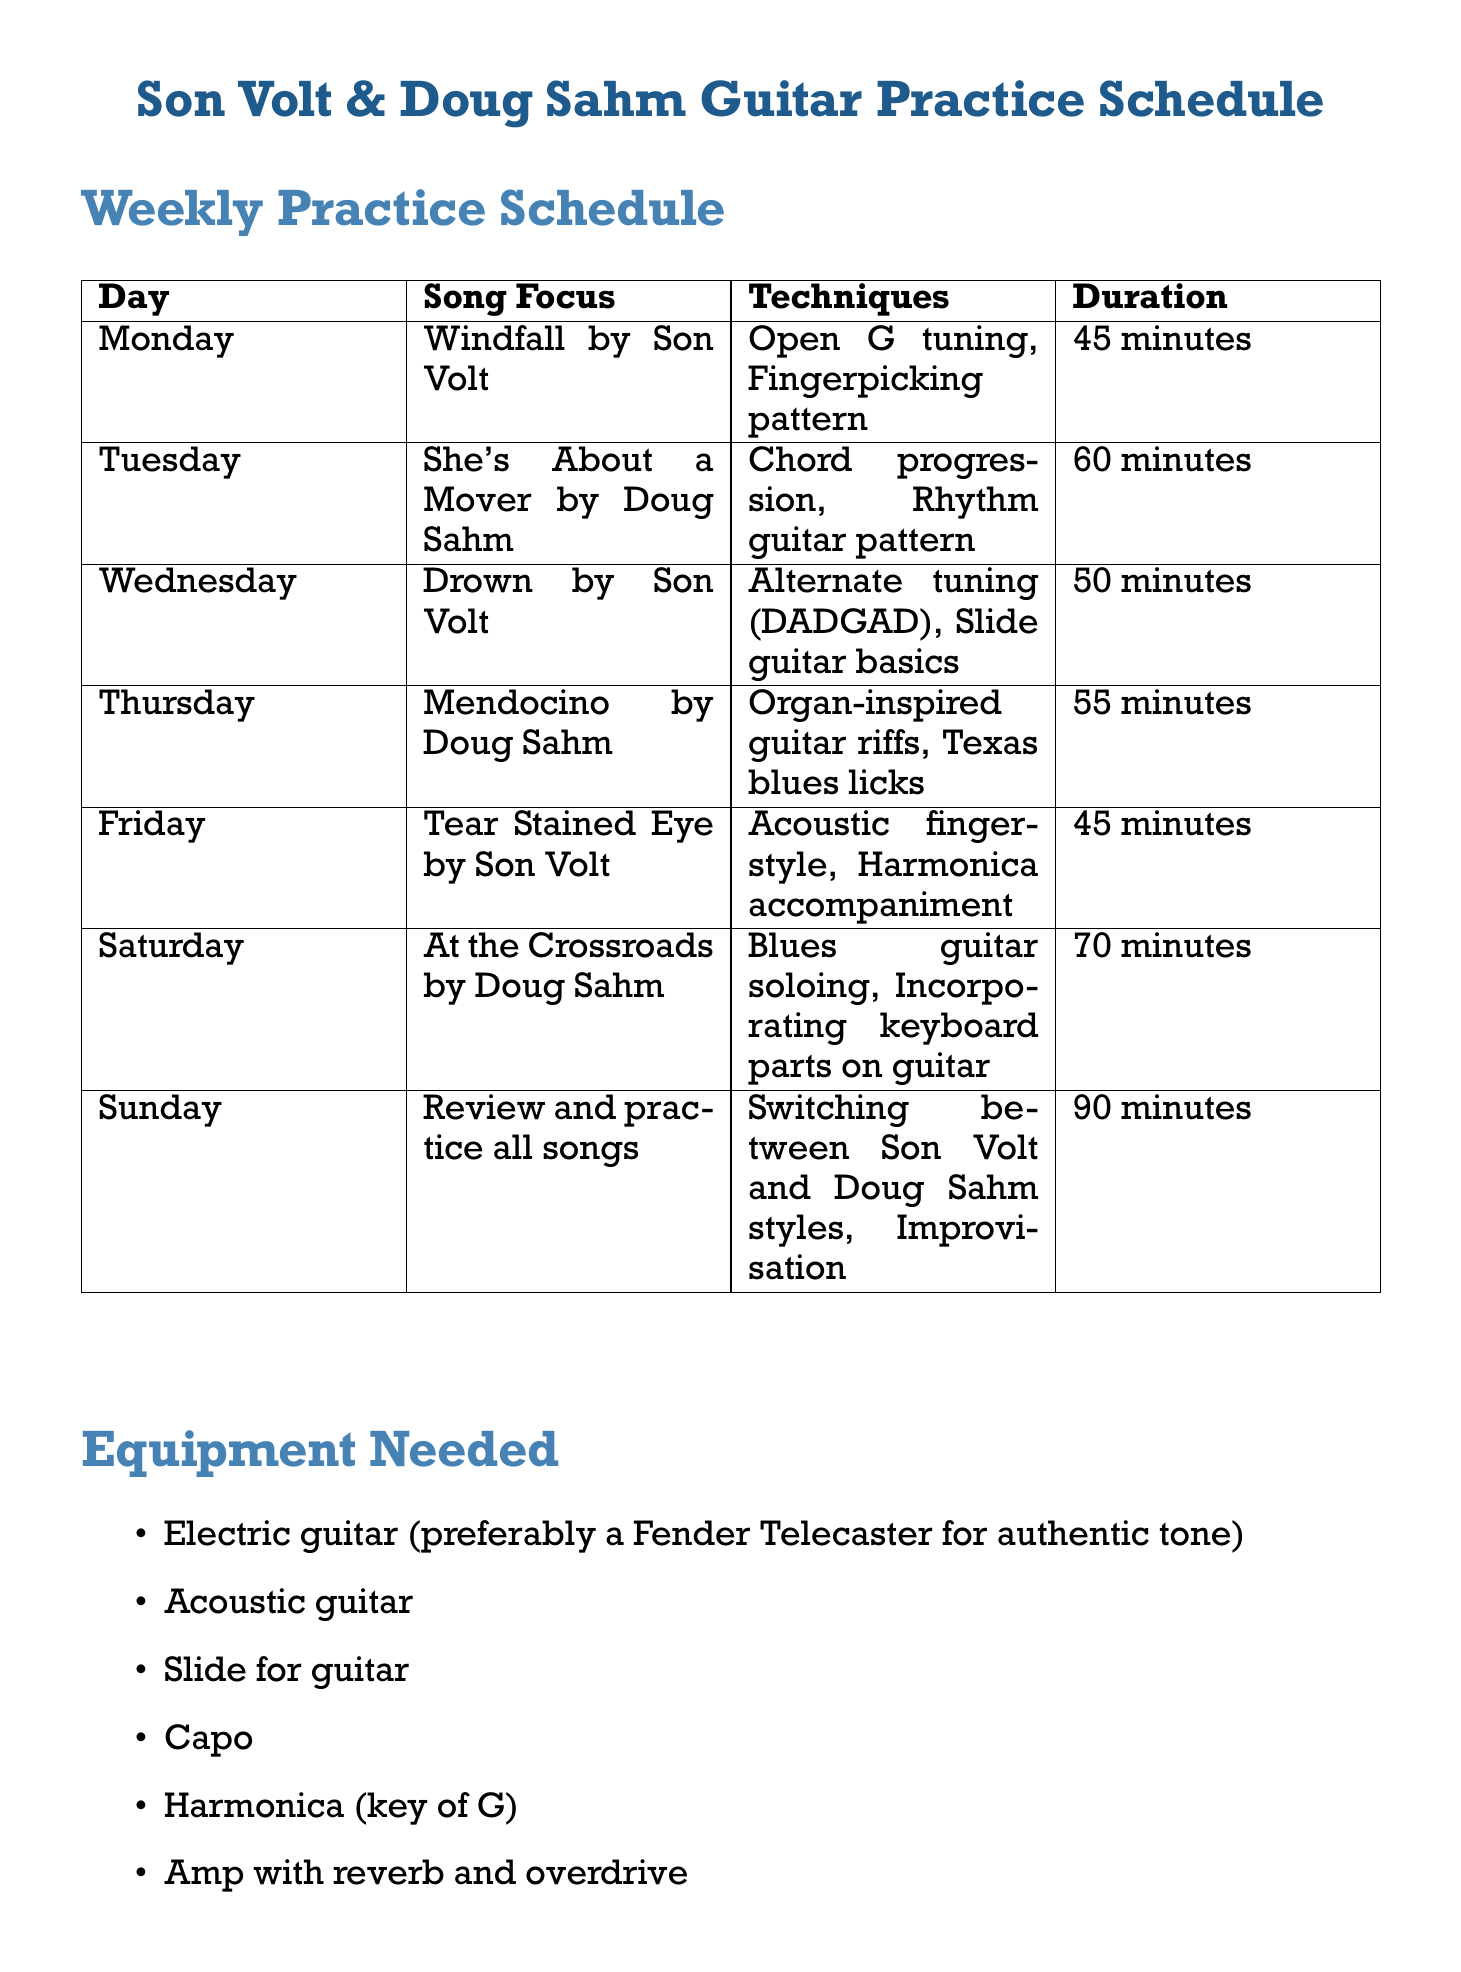What song is focused on Monday? The document specifies "Windfall by Son Volt" as the song for Monday's practice.
Answer: Windfall by Son Volt How long is the practice duration for "She's About a Mover"? The document states that the practice duration for "She's About a Mover" is 60 minutes.
Answer: 60 minutes What technique is practiced on Friday? The document lists "Acoustic fingerstyle" and "Harmonica accompaniment" as techniques for Friday's practice.
Answer: Acoustic fingerstyle Which day focuses on reviewing all songs? The document indicates that Sunday is the day focused on reviewing and practicing all songs.
Answer: Sunday How many minutes are allocated for Saturday's practice? The document specifies that Saturday's practice duration is 70 minutes.
Answer: 70 minutes What additional task is suggested for Wednesday? The document notes that the additional task for Wednesday is "Write a comparison between Son Volt and Uncle Tupelo for blog."
Answer: Write a comparison between Son Volt and Uncle Tupelo for blog What type of guitar is recommended for an authentic tone? The document mentions that an "Electric guitar (preferably a Fender Telecaster for authentic tone)" is needed.
Answer: Fender Telecaster What is one of the long-term goals stated in the document? The document lists multiple long-term goals, one of which is to "Master 10 Son Volt songs and 10 Doug Sahm songs within 3 months."
Answer: Master 10 Son Volt songs and 10 Doug Sahm songs within 3 months 